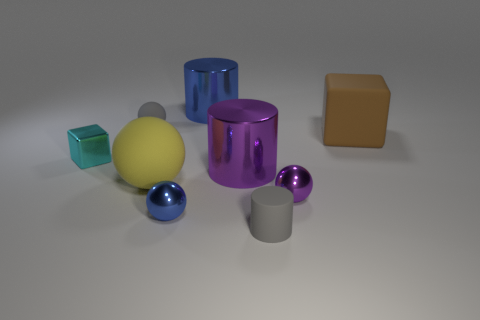There is a big brown object; is its shape the same as the small matte object that is behind the gray rubber cylinder?
Give a very brief answer. No. What material is the cyan object?
Offer a terse response. Metal. What number of shiny things are blue cylinders or large cylinders?
Your response must be concise. 2. Is the number of small blue metal objects left of the tiny purple metallic thing less than the number of objects on the left side of the blue metal sphere?
Provide a succinct answer. Yes. There is a blue metallic object that is in front of the big rubber thing left of the small blue shiny sphere; are there any big blue cylinders on the left side of it?
Your response must be concise. No. There is a tiny metal object on the left side of the small gray matte ball; is its shape the same as the gray object that is in front of the large sphere?
Your answer should be very brief. No. There is a gray ball that is the same size as the purple shiny ball; what is it made of?
Your answer should be very brief. Rubber. Do the small ball behind the large yellow rubber ball and the gray thing in front of the big brown matte block have the same material?
Make the answer very short. Yes. The brown thing that is the same size as the purple cylinder is what shape?
Your response must be concise. Cube. What number of other objects are there of the same color as the large matte ball?
Your answer should be compact. 0. 